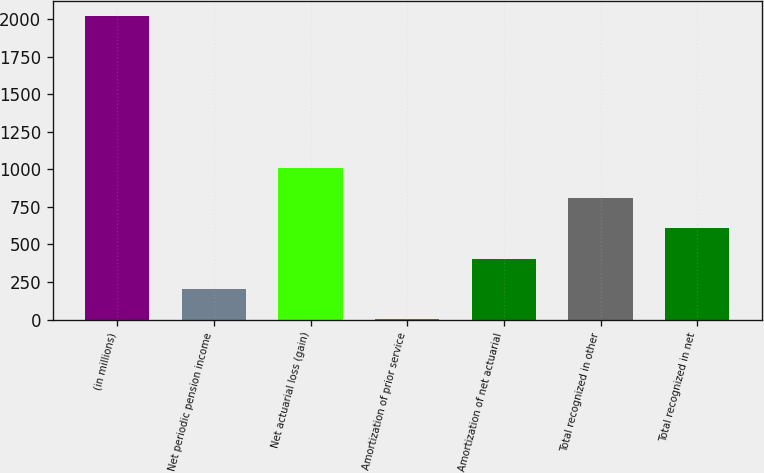<chart> <loc_0><loc_0><loc_500><loc_500><bar_chart><fcel>(in millions)<fcel>Net periodic pension income<fcel>Net actuarial loss (gain)<fcel>Amortization of prior service<fcel>Amortization of net actuarial<fcel>Total recognized in other<fcel>Total recognized in net<nl><fcel>2018<fcel>202.7<fcel>1009.5<fcel>1<fcel>404.4<fcel>807.8<fcel>606.1<nl></chart> 